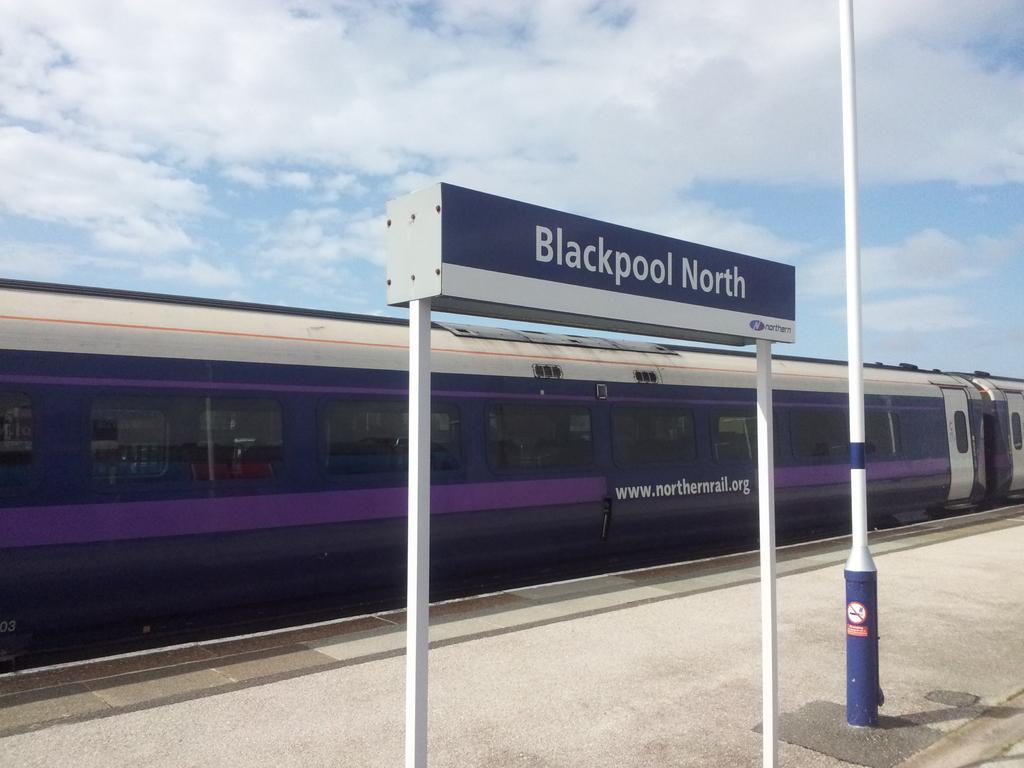Please provide a concise description of this image. In this image we can see a locomotive, platform, name board, pole and sky with clouds. 